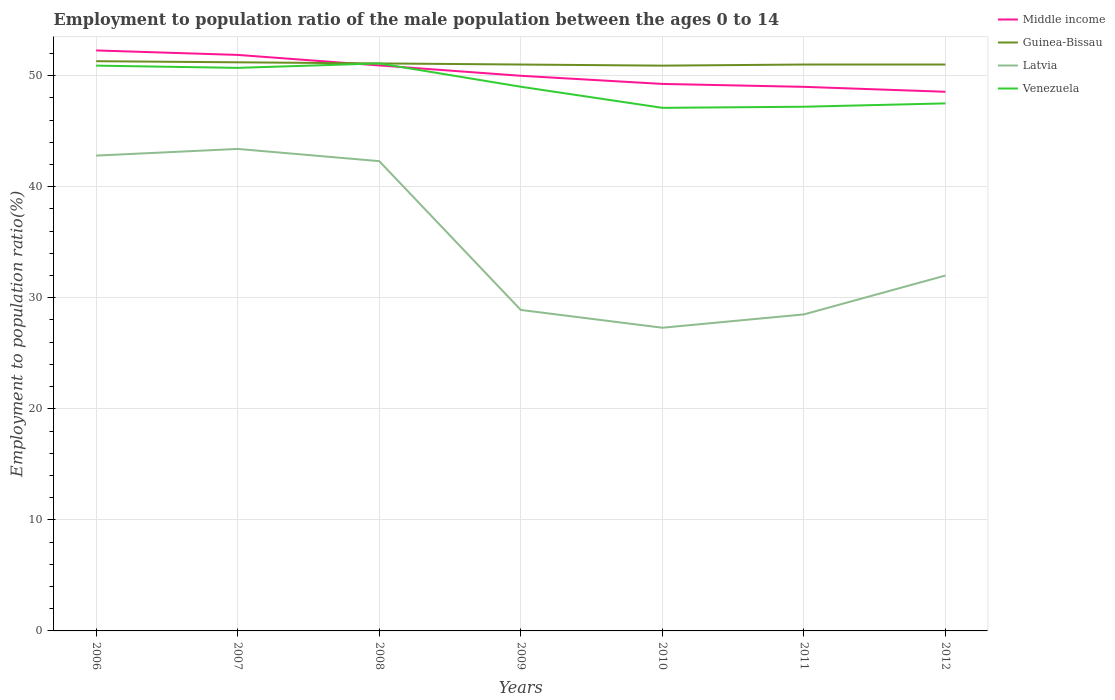How many different coloured lines are there?
Ensure brevity in your answer.  4. Does the line corresponding to Middle income intersect with the line corresponding to Venezuela?
Offer a very short reply. Yes. Is the number of lines equal to the number of legend labels?
Ensure brevity in your answer.  Yes. Across all years, what is the maximum employment to population ratio in Latvia?
Give a very brief answer. 27.3. What is the total employment to population ratio in Latvia in the graph?
Your answer should be very brief. 13.9. What is the difference between the highest and the second highest employment to population ratio in Latvia?
Your answer should be compact. 16.1. What is the difference between the highest and the lowest employment to population ratio in Middle income?
Keep it short and to the point. 3. Is the employment to population ratio in Venezuela strictly greater than the employment to population ratio in Latvia over the years?
Keep it short and to the point. No. How many lines are there?
Your response must be concise. 4. How many years are there in the graph?
Make the answer very short. 7. What is the difference between two consecutive major ticks on the Y-axis?
Offer a very short reply. 10. Does the graph contain grids?
Ensure brevity in your answer.  Yes. Where does the legend appear in the graph?
Your answer should be compact. Top right. How many legend labels are there?
Make the answer very short. 4. What is the title of the graph?
Make the answer very short. Employment to population ratio of the male population between the ages 0 to 14. What is the Employment to population ratio(%) in Middle income in 2006?
Your response must be concise. 52.27. What is the Employment to population ratio(%) of Guinea-Bissau in 2006?
Offer a very short reply. 51.3. What is the Employment to population ratio(%) in Latvia in 2006?
Ensure brevity in your answer.  42.8. What is the Employment to population ratio(%) of Venezuela in 2006?
Give a very brief answer. 50.9. What is the Employment to population ratio(%) of Middle income in 2007?
Your response must be concise. 51.87. What is the Employment to population ratio(%) in Guinea-Bissau in 2007?
Make the answer very short. 51.2. What is the Employment to population ratio(%) in Latvia in 2007?
Provide a short and direct response. 43.4. What is the Employment to population ratio(%) in Venezuela in 2007?
Your response must be concise. 50.7. What is the Employment to population ratio(%) in Middle income in 2008?
Give a very brief answer. 50.92. What is the Employment to population ratio(%) in Guinea-Bissau in 2008?
Give a very brief answer. 51.1. What is the Employment to population ratio(%) in Latvia in 2008?
Your response must be concise. 42.3. What is the Employment to population ratio(%) of Venezuela in 2008?
Your response must be concise. 51.1. What is the Employment to population ratio(%) of Middle income in 2009?
Keep it short and to the point. 49.99. What is the Employment to population ratio(%) in Latvia in 2009?
Keep it short and to the point. 28.9. What is the Employment to population ratio(%) in Venezuela in 2009?
Your answer should be very brief. 49. What is the Employment to population ratio(%) in Middle income in 2010?
Your answer should be very brief. 49.25. What is the Employment to population ratio(%) in Guinea-Bissau in 2010?
Offer a terse response. 50.9. What is the Employment to population ratio(%) in Latvia in 2010?
Offer a very short reply. 27.3. What is the Employment to population ratio(%) in Venezuela in 2010?
Give a very brief answer. 47.1. What is the Employment to population ratio(%) of Middle income in 2011?
Provide a short and direct response. 48.99. What is the Employment to population ratio(%) in Guinea-Bissau in 2011?
Provide a succinct answer. 51. What is the Employment to population ratio(%) of Venezuela in 2011?
Offer a very short reply. 47.2. What is the Employment to population ratio(%) of Middle income in 2012?
Your answer should be compact. 48.55. What is the Employment to population ratio(%) of Venezuela in 2012?
Your answer should be compact. 47.5. Across all years, what is the maximum Employment to population ratio(%) in Middle income?
Offer a very short reply. 52.27. Across all years, what is the maximum Employment to population ratio(%) of Guinea-Bissau?
Your answer should be compact. 51.3. Across all years, what is the maximum Employment to population ratio(%) in Latvia?
Provide a succinct answer. 43.4. Across all years, what is the maximum Employment to population ratio(%) in Venezuela?
Your response must be concise. 51.1. Across all years, what is the minimum Employment to population ratio(%) in Middle income?
Give a very brief answer. 48.55. Across all years, what is the minimum Employment to population ratio(%) in Guinea-Bissau?
Provide a succinct answer. 50.9. Across all years, what is the minimum Employment to population ratio(%) of Latvia?
Give a very brief answer. 27.3. Across all years, what is the minimum Employment to population ratio(%) in Venezuela?
Provide a succinct answer. 47.1. What is the total Employment to population ratio(%) in Middle income in the graph?
Provide a short and direct response. 351.83. What is the total Employment to population ratio(%) of Guinea-Bissau in the graph?
Your answer should be compact. 357.5. What is the total Employment to population ratio(%) in Latvia in the graph?
Ensure brevity in your answer.  245.2. What is the total Employment to population ratio(%) in Venezuela in the graph?
Give a very brief answer. 343.5. What is the difference between the Employment to population ratio(%) of Middle income in 2006 and that in 2007?
Ensure brevity in your answer.  0.4. What is the difference between the Employment to population ratio(%) of Latvia in 2006 and that in 2007?
Keep it short and to the point. -0.6. What is the difference between the Employment to population ratio(%) of Venezuela in 2006 and that in 2007?
Offer a terse response. 0.2. What is the difference between the Employment to population ratio(%) of Middle income in 2006 and that in 2008?
Keep it short and to the point. 1.35. What is the difference between the Employment to population ratio(%) in Venezuela in 2006 and that in 2008?
Make the answer very short. -0.2. What is the difference between the Employment to population ratio(%) of Middle income in 2006 and that in 2009?
Give a very brief answer. 2.28. What is the difference between the Employment to population ratio(%) in Guinea-Bissau in 2006 and that in 2009?
Provide a short and direct response. 0.3. What is the difference between the Employment to population ratio(%) of Latvia in 2006 and that in 2009?
Ensure brevity in your answer.  13.9. What is the difference between the Employment to population ratio(%) in Venezuela in 2006 and that in 2009?
Keep it short and to the point. 1.9. What is the difference between the Employment to population ratio(%) in Middle income in 2006 and that in 2010?
Offer a very short reply. 3.01. What is the difference between the Employment to population ratio(%) in Guinea-Bissau in 2006 and that in 2010?
Make the answer very short. 0.4. What is the difference between the Employment to population ratio(%) of Venezuela in 2006 and that in 2010?
Your response must be concise. 3.8. What is the difference between the Employment to population ratio(%) in Middle income in 2006 and that in 2011?
Offer a very short reply. 3.28. What is the difference between the Employment to population ratio(%) of Latvia in 2006 and that in 2011?
Your response must be concise. 14.3. What is the difference between the Employment to population ratio(%) in Venezuela in 2006 and that in 2011?
Offer a terse response. 3.7. What is the difference between the Employment to population ratio(%) of Middle income in 2006 and that in 2012?
Provide a succinct answer. 3.72. What is the difference between the Employment to population ratio(%) of Venezuela in 2006 and that in 2012?
Offer a terse response. 3.4. What is the difference between the Employment to population ratio(%) in Middle income in 2007 and that in 2008?
Keep it short and to the point. 0.95. What is the difference between the Employment to population ratio(%) in Guinea-Bissau in 2007 and that in 2008?
Provide a short and direct response. 0.1. What is the difference between the Employment to population ratio(%) of Latvia in 2007 and that in 2008?
Provide a short and direct response. 1.1. What is the difference between the Employment to population ratio(%) of Middle income in 2007 and that in 2009?
Your response must be concise. 1.88. What is the difference between the Employment to population ratio(%) of Guinea-Bissau in 2007 and that in 2009?
Make the answer very short. 0.2. What is the difference between the Employment to population ratio(%) of Latvia in 2007 and that in 2009?
Provide a succinct answer. 14.5. What is the difference between the Employment to population ratio(%) in Venezuela in 2007 and that in 2009?
Provide a succinct answer. 1.7. What is the difference between the Employment to population ratio(%) in Middle income in 2007 and that in 2010?
Ensure brevity in your answer.  2.61. What is the difference between the Employment to population ratio(%) in Venezuela in 2007 and that in 2010?
Provide a succinct answer. 3.6. What is the difference between the Employment to population ratio(%) of Middle income in 2007 and that in 2011?
Offer a very short reply. 2.88. What is the difference between the Employment to population ratio(%) in Guinea-Bissau in 2007 and that in 2011?
Make the answer very short. 0.2. What is the difference between the Employment to population ratio(%) in Latvia in 2007 and that in 2011?
Offer a terse response. 14.9. What is the difference between the Employment to population ratio(%) of Middle income in 2007 and that in 2012?
Offer a very short reply. 3.32. What is the difference between the Employment to population ratio(%) in Guinea-Bissau in 2007 and that in 2012?
Your answer should be compact. 0.2. What is the difference between the Employment to population ratio(%) in Latvia in 2007 and that in 2012?
Make the answer very short. 11.4. What is the difference between the Employment to population ratio(%) in Venezuela in 2007 and that in 2012?
Offer a terse response. 3.2. What is the difference between the Employment to population ratio(%) in Middle income in 2008 and that in 2009?
Provide a short and direct response. 0.93. What is the difference between the Employment to population ratio(%) of Latvia in 2008 and that in 2009?
Provide a succinct answer. 13.4. What is the difference between the Employment to population ratio(%) in Middle income in 2008 and that in 2010?
Offer a terse response. 1.66. What is the difference between the Employment to population ratio(%) in Venezuela in 2008 and that in 2010?
Make the answer very short. 4. What is the difference between the Employment to population ratio(%) of Middle income in 2008 and that in 2011?
Ensure brevity in your answer.  1.93. What is the difference between the Employment to population ratio(%) of Venezuela in 2008 and that in 2011?
Provide a succinct answer. 3.9. What is the difference between the Employment to population ratio(%) of Middle income in 2008 and that in 2012?
Give a very brief answer. 2.37. What is the difference between the Employment to population ratio(%) in Venezuela in 2008 and that in 2012?
Ensure brevity in your answer.  3.6. What is the difference between the Employment to population ratio(%) in Middle income in 2009 and that in 2010?
Ensure brevity in your answer.  0.73. What is the difference between the Employment to population ratio(%) of Latvia in 2009 and that in 2010?
Offer a very short reply. 1.6. What is the difference between the Employment to population ratio(%) of Venezuela in 2009 and that in 2010?
Your answer should be very brief. 1.9. What is the difference between the Employment to population ratio(%) of Middle income in 2009 and that in 2011?
Provide a short and direct response. 1. What is the difference between the Employment to population ratio(%) in Latvia in 2009 and that in 2011?
Ensure brevity in your answer.  0.4. What is the difference between the Employment to population ratio(%) in Venezuela in 2009 and that in 2011?
Provide a succinct answer. 1.8. What is the difference between the Employment to population ratio(%) of Middle income in 2009 and that in 2012?
Provide a short and direct response. 1.44. What is the difference between the Employment to population ratio(%) of Guinea-Bissau in 2009 and that in 2012?
Keep it short and to the point. 0. What is the difference between the Employment to population ratio(%) of Middle income in 2010 and that in 2011?
Give a very brief answer. 0.26. What is the difference between the Employment to population ratio(%) in Guinea-Bissau in 2010 and that in 2011?
Offer a very short reply. -0.1. What is the difference between the Employment to population ratio(%) of Middle income in 2010 and that in 2012?
Ensure brevity in your answer.  0.71. What is the difference between the Employment to population ratio(%) in Middle income in 2011 and that in 2012?
Offer a terse response. 0.44. What is the difference between the Employment to population ratio(%) of Guinea-Bissau in 2011 and that in 2012?
Your response must be concise. 0. What is the difference between the Employment to population ratio(%) of Latvia in 2011 and that in 2012?
Make the answer very short. -3.5. What is the difference between the Employment to population ratio(%) of Middle income in 2006 and the Employment to population ratio(%) of Guinea-Bissau in 2007?
Your answer should be compact. 1.07. What is the difference between the Employment to population ratio(%) in Middle income in 2006 and the Employment to population ratio(%) in Latvia in 2007?
Make the answer very short. 8.87. What is the difference between the Employment to population ratio(%) in Middle income in 2006 and the Employment to population ratio(%) in Venezuela in 2007?
Offer a terse response. 1.57. What is the difference between the Employment to population ratio(%) of Guinea-Bissau in 2006 and the Employment to population ratio(%) of Latvia in 2007?
Provide a succinct answer. 7.9. What is the difference between the Employment to population ratio(%) in Middle income in 2006 and the Employment to population ratio(%) in Guinea-Bissau in 2008?
Provide a short and direct response. 1.17. What is the difference between the Employment to population ratio(%) of Middle income in 2006 and the Employment to population ratio(%) of Latvia in 2008?
Your answer should be very brief. 9.97. What is the difference between the Employment to population ratio(%) of Middle income in 2006 and the Employment to population ratio(%) of Venezuela in 2008?
Offer a very short reply. 1.17. What is the difference between the Employment to population ratio(%) of Guinea-Bissau in 2006 and the Employment to population ratio(%) of Latvia in 2008?
Provide a short and direct response. 9. What is the difference between the Employment to population ratio(%) in Guinea-Bissau in 2006 and the Employment to population ratio(%) in Venezuela in 2008?
Keep it short and to the point. 0.2. What is the difference between the Employment to population ratio(%) of Latvia in 2006 and the Employment to population ratio(%) of Venezuela in 2008?
Keep it short and to the point. -8.3. What is the difference between the Employment to population ratio(%) in Middle income in 2006 and the Employment to population ratio(%) in Guinea-Bissau in 2009?
Offer a terse response. 1.27. What is the difference between the Employment to population ratio(%) of Middle income in 2006 and the Employment to population ratio(%) of Latvia in 2009?
Offer a terse response. 23.37. What is the difference between the Employment to population ratio(%) of Middle income in 2006 and the Employment to population ratio(%) of Venezuela in 2009?
Your answer should be very brief. 3.27. What is the difference between the Employment to population ratio(%) of Guinea-Bissau in 2006 and the Employment to population ratio(%) of Latvia in 2009?
Your answer should be compact. 22.4. What is the difference between the Employment to population ratio(%) in Guinea-Bissau in 2006 and the Employment to population ratio(%) in Venezuela in 2009?
Ensure brevity in your answer.  2.3. What is the difference between the Employment to population ratio(%) of Middle income in 2006 and the Employment to population ratio(%) of Guinea-Bissau in 2010?
Your answer should be very brief. 1.37. What is the difference between the Employment to population ratio(%) in Middle income in 2006 and the Employment to population ratio(%) in Latvia in 2010?
Keep it short and to the point. 24.97. What is the difference between the Employment to population ratio(%) in Middle income in 2006 and the Employment to population ratio(%) in Venezuela in 2010?
Keep it short and to the point. 5.17. What is the difference between the Employment to population ratio(%) in Middle income in 2006 and the Employment to population ratio(%) in Guinea-Bissau in 2011?
Your answer should be compact. 1.27. What is the difference between the Employment to population ratio(%) of Middle income in 2006 and the Employment to population ratio(%) of Latvia in 2011?
Keep it short and to the point. 23.77. What is the difference between the Employment to population ratio(%) in Middle income in 2006 and the Employment to population ratio(%) in Venezuela in 2011?
Ensure brevity in your answer.  5.07. What is the difference between the Employment to population ratio(%) of Guinea-Bissau in 2006 and the Employment to population ratio(%) of Latvia in 2011?
Offer a very short reply. 22.8. What is the difference between the Employment to population ratio(%) in Guinea-Bissau in 2006 and the Employment to population ratio(%) in Venezuela in 2011?
Your response must be concise. 4.1. What is the difference between the Employment to population ratio(%) of Latvia in 2006 and the Employment to population ratio(%) of Venezuela in 2011?
Your answer should be compact. -4.4. What is the difference between the Employment to population ratio(%) in Middle income in 2006 and the Employment to population ratio(%) in Guinea-Bissau in 2012?
Provide a short and direct response. 1.27. What is the difference between the Employment to population ratio(%) in Middle income in 2006 and the Employment to population ratio(%) in Latvia in 2012?
Offer a terse response. 20.27. What is the difference between the Employment to population ratio(%) of Middle income in 2006 and the Employment to population ratio(%) of Venezuela in 2012?
Your answer should be compact. 4.77. What is the difference between the Employment to population ratio(%) of Guinea-Bissau in 2006 and the Employment to population ratio(%) of Latvia in 2012?
Provide a short and direct response. 19.3. What is the difference between the Employment to population ratio(%) of Guinea-Bissau in 2006 and the Employment to population ratio(%) of Venezuela in 2012?
Keep it short and to the point. 3.8. What is the difference between the Employment to population ratio(%) in Middle income in 2007 and the Employment to population ratio(%) in Guinea-Bissau in 2008?
Provide a succinct answer. 0.77. What is the difference between the Employment to population ratio(%) in Middle income in 2007 and the Employment to population ratio(%) in Latvia in 2008?
Offer a terse response. 9.57. What is the difference between the Employment to population ratio(%) of Middle income in 2007 and the Employment to population ratio(%) of Venezuela in 2008?
Provide a short and direct response. 0.77. What is the difference between the Employment to population ratio(%) of Middle income in 2007 and the Employment to population ratio(%) of Guinea-Bissau in 2009?
Provide a succinct answer. 0.87. What is the difference between the Employment to population ratio(%) of Middle income in 2007 and the Employment to population ratio(%) of Latvia in 2009?
Keep it short and to the point. 22.97. What is the difference between the Employment to population ratio(%) of Middle income in 2007 and the Employment to population ratio(%) of Venezuela in 2009?
Your answer should be very brief. 2.87. What is the difference between the Employment to population ratio(%) of Guinea-Bissau in 2007 and the Employment to population ratio(%) of Latvia in 2009?
Give a very brief answer. 22.3. What is the difference between the Employment to population ratio(%) in Guinea-Bissau in 2007 and the Employment to population ratio(%) in Venezuela in 2009?
Your answer should be very brief. 2.2. What is the difference between the Employment to population ratio(%) of Middle income in 2007 and the Employment to population ratio(%) of Guinea-Bissau in 2010?
Keep it short and to the point. 0.97. What is the difference between the Employment to population ratio(%) in Middle income in 2007 and the Employment to population ratio(%) in Latvia in 2010?
Provide a succinct answer. 24.57. What is the difference between the Employment to population ratio(%) in Middle income in 2007 and the Employment to population ratio(%) in Venezuela in 2010?
Your response must be concise. 4.77. What is the difference between the Employment to population ratio(%) of Guinea-Bissau in 2007 and the Employment to population ratio(%) of Latvia in 2010?
Your answer should be very brief. 23.9. What is the difference between the Employment to population ratio(%) of Latvia in 2007 and the Employment to population ratio(%) of Venezuela in 2010?
Make the answer very short. -3.7. What is the difference between the Employment to population ratio(%) in Middle income in 2007 and the Employment to population ratio(%) in Guinea-Bissau in 2011?
Provide a succinct answer. 0.87. What is the difference between the Employment to population ratio(%) in Middle income in 2007 and the Employment to population ratio(%) in Latvia in 2011?
Ensure brevity in your answer.  23.37. What is the difference between the Employment to population ratio(%) in Middle income in 2007 and the Employment to population ratio(%) in Venezuela in 2011?
Your answer should be compact. 4.67. What is the difference between the Employment to population ratio(%) in Guinea-Bissau in 2007 and the Employment to population ratio(%) in Latvia in 2011?
Keep it short and to the point. 22.7. What is the difference between the Employment to population ratio(%) in Middle income in 2007 and the Employment to population ratio(%) in Guinea-Bissau in 2012?
Keep it short and to the point. 0.87. What is the difference between the Employment to population ratio(%) in Middle income in 2007 and the Employment to population ratio(%) in Latvia in 2012?
Offer a terse response. 19.87. What is the difference between the Employment to population ratio(%) of Middle income in 2007 and the Employment to population ratio(%) of Venezuela in 2012?
Make the answer very short. 4.37. What is the difference between the Employment to population ratio(%) in Latvia in 2007 and the Employment to population ratio(%) in Venezuela in 2012?
Offer a terse response. -4.1. What is the difference between the Employment to population ratio(%) in Middle income in 2008 and the Employment to population ratio(%) in Guinea-Bissau in 2009?
Your response must be concise. -0.08. What is the difference between the Employment to population ratio(%) in Middle income in 2008 and the Employment to population ratio(%) in Latvia in 2009?
Provide a succinct answer. 22.02. What is the difference between the Employment to population ratio(%) in Middle income in 2008 and the Employment to population ratio(%) in Venezuela in 2009?
Offer a very short reply. 1.92. What is the difference between the Employment to population ratio(%) in Guinea-Bissau in 2008 and the Employment to population ratio(%) in Latvia in 2009?
Your response must be concise. 22.2. What is the difference between the Employment to population ratio(%) in Guinea-Bissau in 2008 and the Employment to population ratio(%) in Venezuela in 2009?
Ensure brevity in your answer.  2.1. What is the difference between the Employment to population ratio(%) of Latvia in 2008 and the Employment to population ratio(%) of Venezuela in 2009?
Give a very brief answer. -6.7. What is the difference between the Employment to population ratio(%) of Middle income in 2008 and the Employment to population ratio(%) of Guinea-Bissau in 2010?
Your response must be concise. 0.02. What is the difference between the Employment to population ratio(%) of Middle income in 2008 and the Employment to population ratio(%) of Latvia in 2010?
Your answer should be compact. 23.62. What is the difference between the Employment to population ratio(%) in Middle income in 2008 and the Employment to population ratio(%) in Venezuela in 2010?
Give a very brief answer. 3.82. What is the difference between the Employment to population ratio(%) in Guinea-Bissau in 2008 and the Employment to population ratio(%) in Latvia in 2010?
Ensure brevity in your answer.  23.8. What is the difference between the Employment to population ratio(%) in Middle income in 2008 and the Employment to population ratio(%) in Guinea-Bissau in 2011?
Ensure brevity in your answer.  -0.08. What is the difference between the Employment to population ratio(%) of Middle income in 2008 and the Employment to population ratio(%) of Latvia in 2011?
Your answer should be compact. 22.42. What is the difference between the Employment to population ratio(%) of Middle income in 2008 and the Employment to population ratio(%) of Venezuela in 2011?
Your answer should be very brief. 3.72. What is the difference between the Employment to population ratio(%) of Guinea-Bissau in 2008 and the Employment to population ratio(%) of Latvia in 2011?
Give a very brief answer. 22.6. What is the difference between the Employment to population ratio(%) in Middle income in 2008 and the Employment to population ratio(%) in Guinea-Bissau in 2012?
Offer a terse response. -0.08. What is the difference between the Employment to population ratio(%) in Middle income in 2008 and the Employment to population ratio(%) in Latvia in 2012?
Your answer should be compact. 18.92. What is the difference between the Employment to population ratio(%) in Middle income in 2008 and the Employment to population ratio(%) in Venezuela in 2012?
Offer a terse response. 3.42. What is the difference between the Employment to population ratio(%) in Guinea-Bissau in 2008 and the Employment to population ratio(%) in Venezuela in 2012?
Provide a short and direct response. 3.6. What is the difference between the Employment to population ratio(%) in Latvia in 2008 and the Employment to population ratio(%) in Venezuela in 2012?
Offer a terse response. -5.2. What is the difference between the Employment to population ratio(%) in Middle income in 2009 and the Employment to population ratio(%) in Guinea-Bissau in 2010?
Make the answer very short. -0.91. What is the difference between the Employment to population ratio(%) of Middle income in 2009 and the Employment to population ratio(%) of Latvia in 2010?
Offer a terse response. 22.69. What is the difference between the Employment to population ratio(%) in Middle income in 2009 and the Employment to population ratio(%) in Venezuela in 2010?
Your answer should be very brief. 2.89. What is the difference between the Employment to population ratio(%) in Guinea-Bissau in 2009 and the Employment to population ratio(%) in Latvia in 2010?
Ensure brevity in your answer.  23.7. What is the difference between the Employment to population ratio(%) of Guinea-Bissau in 2009 and the Employment to population ratio(%) of Venezuela in 2010?
Your answer should be very brief. 3.9. What is the difference between the Employment to population ratio(%) in Latvia in 2009 and the Employment to population ratio(%) in Venezuela in 2010?
Make the answer very short. -18.2. What is the difference between the Employment to population ratio(%) in Middle income in 2009 and the Employment to population ratio(%) in Guinea-Bissau in 2011?
Make the answer very short. -1.01. What is the difference between the Employment to population ratio(%) in Middle income in 2009 and the Employment to population ratio(%) in Latvia in 2011?
Provide a short and direct response. 21.49. What is the difference between the Employment to population ratio(%) of Middle income in 2009 and the Employment to population ratio(%) of Venezuela in 2011?
Provide a short and direct response. 2.79. What is the difference between the Employment to population ratio(%) of Guinea-Bissau in 2009 and the Employment to population ratio(%) of Venezuela in 2011?
Make the answer very short. 3.8. What is the difference between the Employment to population ratio(%) of Latvia in 2009 and the Employment to population ratio(%) of Venezuela in 2011?
Offer a very short reply. -18.3. What is the difference between the Employment to population ratio(%) of Middle income in 2009 and the Employment to population ratio(%) of Guinea-Bissau in 2012?
Ensure brevity in your answer.  -1.01. What is the difference between the Employment to population ratio(%) of Middle income in 2009 and the Employment to population ratio(%) of Latvia in 2012?
Provide a short and direct response. 17.99. What is the difference between the Employment to population ratio(%) in Middle income in 2009 and the Employment to population ratio(%) in Venezuela in 2012?
Keep it short and to the point. 2.49. What is the difference between the Employment to population ratio(%) in Guinea-Bissau in 2009 and the Employment to population ratio(%) in Latvia in 2012?
Provide a succinct answer. 19. What is the difference between the Employment to population ratio(%) of Latvia in 2009 and the Employment to population ratio(%) of Venezuela in 2012?
Provide a succinct answer. -18.6. What is the difference between the Employment to population ratio(%) of Middle income in 2010 and the Employment to population ratio(%) of Guinea-Bissau in 2011?
Keep it short and to the point. -1.75. What is the difference between the Employment to population ratio(%) of Middle income in 2010 and the Employment to population ratio(%) of Latvia in 2011?
Offer a terse response. 20.75. What is the difference between the Employment to population ratio(%) in Middle income in 2010 and the Employment to population ratio(%) in Venezuela in 2011?
Keep it short and to the point. 2.05. What is the difference between the Employment to population ratio(%) in Guinea-Bissau in 2010 and the Employment to population ratio(%) in Latvia in 2011?
Ensure brevity in your answer.  22.4. What is the difference between the Employment to population ratio(%) of Latvia in 2010 and the Employment to population ratio(%) of Venezuela in 2011?
Give a very brief answer. -19.9. What is the difference between the Employment to population ratio(%) of Middle income in 2010 and the Employment to population ratio(%) of Guinea-Bissau in 2012?
Offer a very short reply. -1.75. What is the difference between the Employment to population ratio(%) in Middle income in 2010 and the Employment to population ratio(%) in Latvia in 2012?
Offer a terse response. 17.25. What is the difference between the Employment to population ratio(%) in Middle income in 2010 and the Employment to population ratio(%) in Venezuela in 2012?
Ensure brevity in your answer.  1.75. What is the difference between the Employment to population ratio(%) of Latvia in 2010 and the Employment to population ratio(%) of Venezuela in 2012?
Ensure brevity in your answer.  -20.2. What is the difference between the Employment to population ratio(%) in Middle income in 2011 and the Employment to population ratio(%) in Guinea-Bissau in 2012?
Your response must be concise. -2.01. What is the difference between the Employment to population ratio(%) in Middle income in 2011 and the Employment to population ratio(%) in Latvia in 2012?
Offer a terse response. 16.99. What is the difference between the Employment to population ratio(%) in Middle income in 2011 and the Employment to population ratio(%) in Venezuela in 2012?
Your answer should be compact. 1.49. What is the difference between the Employment to population ratio(%) in Guinea-Bissau in 2011 and the Employment to population ratio(%) in Latvia in 2012?
Provide a short and direct response. 19. What is the difference between the Employment to population ratio(%) of Guinea-Bissau in 2011 and the Employment to population ratio(%) of Venezuela in 2012?
Provide a succinct answer. 3.5. What is the average Employment to population ratio(%) in Middle income per year?
Make the answer very short. 50.26. What is the average Employment to population ratio(%) of Guinea-Bissau per year?
Your answer should be very brief. 51.07. What is the average Employment to population ratio(%) of Latvia per year?
Your answer should be very brief. 35.03. What is the average Employment to population ratio(%) of Venezuela per year?
Make the answer very short. 49.07. In the year 2006, what is the difference between the Employment to population ratio(%) in Middle income and Employment to population ratio(%) in Guinea-Bissau?
Keep it short and to the point. 0.97. In the year 2006, what is the difference between the Employment to population ratio(%) in Middle income and Employment to population ratio(%) in Latvia?
Provide a succinct answer. 9.47. In the year 2006, what is the difference between the Employment to population ratio(%) in Middle income and Employment to population ratio(%) in Venezuela?
Your answer should be very brief. 1.37. In the year 2006, what is the difference between the Employment to population ratio(%) of Guinea-Bissau and Employment to population ratio(%) of Venezuela?
Keep it short and to the point. 0.4. In the year 2007, what is the difference between the Employment to population ratio(%) of Middle income and Employment to population ratio(%) of Guinea-Bissau?
Your answer should be compact. 0.67. In the year 2007, what is the difference between the Employment to population ratio(%) in Middle income and Employment to population ratio(%) in Latvia?
Give a very brief answer. 8.47. In the year 2007, what is the difference between the Employment to population ratio(%) of Middle income and Employment to population ratio(%) of Venezuela?
Provide a short and direct response. 1.17. In the year 2007, what is the difference between the Employment to population ratio(%) in Guinea-Bissau and Employment to population ratio(%) in Latvia?
Provide a succinct answer. 7.8. In the year 2007, what is the difference between the Employment to population ratio(%) in Guinea-Bissau and Employment to population ratio(%) in Venezuela?
Make the answer very short. 0.5. In the year 2007, what is the difference between the Employment to population ratio(%) in Latvia and Employment to population ratio(%) in Venezuela?
Your answer should be very brief. -7.3. In the year 2008, what is the difference between the Employment to population ratio(%) of Middle income and Employment to population ratio(%) of Guinea-Bissau?
Provide a succinct answer. -0.18. In the year 2008, what is the difference between the Employment to population ratio(%) in Middle income and Employment to population ratio(%) in Latvia?
Make the answer very short. 8.62. In the year 2008, what is the difference between the Employment to population ratio(%) in Middle income and Employment to population ratio(%) in Venezuela?
Provide a short and direct response. -0.18. In the year 2008, what is the difference between the Employment to population ratio(%) of Guinea-Bissau and Employment to population ratio(%) of Venezuela?
Make the answer very short. 0. In the year 2009, what is the difference between the Employment to population ratio(%) in Middle income and Employment to population ratio(%) in Guinea-Bissau?
Your answer should be very brief. -1.01. In the year 2009, what is the difference between the Employment to population ratio(%) in Middle income and Employment to population ratio(%) in Latvia?
Ensure brevity in your answer.  21.09. In the year 2009, what is the difference between the Employment to population ratio(%) in Middle income and Employment to population ratio(%) in Venezuela?
Make the answer very short. 0.99. In the year 2009, what is the difference between the Employment to population ratio(%) of Guinea-Bissau and Employment to population ratio(%) of Latvia?
Ensure brevity in your answer.  22.1. In the year 2009, what is the difference between the Employment to population ratio(%) of Latvia and Employment to population ratio(%) of Venezuela?
Offer a terse response. -20.1. In the year 2010, what is the difference between the Employment to population ratio(%) of Middle income and Employment to population ratio(%) of Guinea-Bissau?
Offer a terse response. -1.65. In the year 2010, what is the difference between the Employment to population ratio(%) of Middle income and Employment to population ratio(%) of Latvia?
Make the answer very short. 21.95. In the year 2010, what is the difference between the Employment to population ratio(%) of Middle income and Employment to population ratio(%) of Venezuela?
Offer a terse response. 2.15. In the year 2010, what is the difference between the Employment to population ratio(%) in Guinea-Bissau and Employment to population ratio(%) in Latvia?
Offer a very short reply. 23.6. In the year 2010, what is the difference between the Employment to population ratio(%) of Latvia and Employment to population ratio(%) of Venezuela?
Your answer should be compact. -19.8. In the year 2011, what is the difference between the Employment to population ratio(%) of Middle income and Employment to population ratio(%) of Guinea-Bissau?
Offer a terse response. -2.01. In the year 2011, what is the difference between the Employment to population ratio(%) of Middle income and Employment to population ratio(%) of Latvia?
Offer a very short reply. 20.49. In the year 2011, what is the difference between the Employment to population ratio(%) of Middle income and Employment to population ratio(%) of Venezuela?
Your answer should be very brief. 1.79. In the year 2011, what is the difference between the Employment to population ratio(%) of Guinea-Bissau and Employment to population ratio(%) of Venezuela?
Give a very brief answer. 3.8. In the year 2011, what is the difference between the Employment to population ratio(%) in Latvia and Employment to population ratio(%) in Venezuela?
Keep it short and to the point. -18.7. In the year 2012, what is the difference between the Employment to population ratio(%) of Middle income and Employment to population ratio(%) of Guinea-Bissau?
Your response must be concise. -2.45. In the year 2012, what is the difference between the Employment to population ratio(%) in Middle income and Employment to population ratio(%) in Latvia?
Your response must be concise. 16.55. In the year 2012, what is the difference between the Employment to population ratio(%) of Middle income and Employment to population ratio(%) of Venezuela?
Offer a terse response. 1.05. In the year 2012, what is the difference between the Employment to population ratio(%) in Latvia and Employment to population ratio(%) in Venezuela?
Offer a terse response. -15.5. What is the ratio of the Employment to population ratio(%) in Guinea-Bissau in 2006 to that in 2007?
Give a very brief answer. 1. What is the ratio of the Employment to population ratio(%) in Latvia in 2006 to that in 2007?
Your answer should be very brief. 0.99. What is the ratio of the Employment to population ratio(%) in Venezuela in 2006 to that in 2007?
Your answer should be very brief. 1. What is the ratio of the Employment to population ratio(%) of Middle income in 2006 to that in 2008?
Provide a succinct answer. 1.03. What is the ratio of the Employment to population ratio(%) of Latvia in 2006 to that in 2008?
Make the answer very short. 1.01. What is the ratio of the Employment to population ratio(%) in Middle income in 2006 to that in 2009?
Keep it short and to the point. 1.05. What is the ratio of the Employment to population ratio(%) of Guinea-Bissau in 2006 to that in 2009?
Offer a terse response. 1.01. What is the ratio of the Employment to population ratio(%) in Latvia in 2006 to that in 2009?
Offer a very short reply. 1.48. What is the ratio of the Employment to population ratio(%) of Venezuela in 2006 to that in 2009?
Your response must be concise. 1.04. What is the ratio of the Employment to population ratio(%) of Middle income in 2006 to that in 2010?
Make the answer very short. 1.06. What is the ratio of the Employment to population ratio(%) of Guinea-Bissau in 2006 to that in 2010?
Offer a very short reply. 1.01. What is the ratio of the Employment to population ratio(%) of Latvia in 2006 to that in 2010?
Keep it short and to the point. 1.57. What is the ratio of the Employment to population ratio(%) of Venezuela in 2006 to that in 2010?
Your answer should be compact. 1.08. What is the ratio of the Employment to population ratio(%) in Middle income in 2006 to that in 2011?
Give a very brief answer. 1.07. What is the ratio of the Employment to population ratio(%) in Guinea-Bissau in 2006 to that in 2011?
Your response must be concise. 1.01. What is the ratio of the Employment to population ratio(%) in Latvia in 2006 to that in 2011?
Provide a short and direct response. 1.5. What is the ratio of the Employment to population ratio(%) in Venezuela in 2006 to that in 2011?
Your response must be concise. 1.08. What is the ratio of the Employment to population ratio(%) of Middle income in 2006 to that in 2012?
Provide a short and direct response. 1.08. What is the ratio of the Employment to population ratio(%) of Guinea-Bissau in 2006 to that in 2012?
Provide a succinct answer. 1.01. What is the ratio of the Employment to population ratio(%) in Latvia in 2006 to that in 2012?
Provide a short and direct response. 1.34. What is the ratio of the Employment to population ratio(%) in Venezuela in 2006 to that in 2012?
Give a very brief answer. 1.07. What is the ratio of the Employment to population ratio(%) of Middle income in 2007 to that in 2008?
Give a very brief answer. 1.02. What is the ratio of the Employment to population ratio(%) of Guinea-Bissau in 2007 to that in 2008?
Your answer should be very brief. 1. What is the ratio of the Employment to population ratio(%) of Middle income in 2007 to that in 2009?
Offer a very short reply. 1.04. What is the ratio of the Employment to population ratio(%) of Guinea-Bissau in 2007 to that in 2009?
Offer a terse response. 1. What is the ratio of the Employment to population ratio(%) in Latvia in 2007 to that in 2009?
Make the answer very short. 1.5. What is the ratio of the Employment to population ratio(%) of Venezuela in 2007 to that in 2009?
Offer a very short reply. 1.03. What is the ratio of the Employment to population ratio(%) in Middle income in 2007 to that in 2010?
Your response must be concise. 1.05. What is the ratio of the Employment to population ratio(%) of Guinea-Bissau in 2007 to that in 2010?
Your answer should be very brief. 1.01. What is the ratio of the Employment to population ratio(%) of Latvia in 2007 to that in 2010?
Keep it short and to the point. 1.59. What is the ratio of the Employment to population ratio(%) in Venezuela in 2007 to that in 2010?
Keep it short and to the point. 1.08. What is the ratio of the Employment to population ratio(%) of Middle income in 2007 to that in 2011?
Give a very brief answer. 1.06. What is the ratio of the Employment to population ratio(%) in Guinea-Bissau in 2007 to that in 2011?
Your response must be concise. 1. What is the ratio of the Employment to population ratio(%) in Latvia in 2007 to that in 2011?
Make the answer very short. 1.52. What is the ratio of the Employment to population ratio(%) in Venezuela in 2007 to that in 2011?
Offer a terse response. 1.07. What is the ratio of the Employment to population ratio(%) of Middle income in 2007 to that in 2012?
Provide a succinct answer. 1.07. What is the ratio of the Employment to population ratio(%) in Guinea-Bissau in 2007 to that in 2012?
Make the answer very short. 1. What is the ratio of the Employment to population ratio(%) of Latvia in 2007 to that in 2012?
Give a very brief answer. 1.36. What is the ratio of the Employment to population ratio(%) of Venezuela in 2007 to that in 2012?
Your answer should be compact. 1.07. What is the ratio of the Employment to population ratio(%) in Middle income in 2008 to that in 2009?
Your answer should be compact. 1.02. What is the ratio of the Employment to population ratio(%) of Guinea-Bissau in 2008 to that in 2009?
Give a very brief answer. 1. What is the ratio of the Employment to population ratio(%) of Latvia in 2008 to that in 2009?
Give a very brief answer. 1.46. What is the ratio of the Employment to population ratio(%) of Venezuela in 2008 to that in 2009?
Offer a very short reply. 1.04. What is the ratio of the Employment to population ratio(%) of Middle income in 2008 to that in 2010?
Offer a very short reply. 1.03. What is the ratio of the Employment to population ratio(%) of Guinea-Bissau in 2008 to that in 2010?
Provide a succinct answer. 1. What is the ratio of the Employment to population ratio(%) in Latvia in 2008 to that in 2010?
Give a very brief answer. 1.55. What is the ratio of the Employment to population ratio(%) of Venezuela in 2008 to that in 2010?
Offer a very short reply. 1.08. What is the ratio of the Employment to population ratio(%) in Middle income in 2008 to that in 2011?
Your response must be concise. 1.04. What is the ratio of the Employment to population ratio(%) of Latvia in 2008 to that in 2011?
Ensure brevity in your answer.  1.48. What is the ratio of the Employment to population ratio(%) of Venezuela in 2008 to that in 2011?
Your response must be concise. 1.08. What is the ratio of the Employment to population ratio(%) of Middle income in 2008 to that in 2012?
Make the answer very short. 1.05. What is the ratio of the Employment to population ratio(%) in Latvia in 2008 to that in 2012?
Make the answer very short. 1.32. What is the ratio of the Employment to population ratio(%) of Venezuela in 2008 to that in 2012?
Your answer should be very brief. 1.08. What is the ratio of the Employment to population ratio(%) in Middle income in 2009 to that in 2010?
Keep it short and to the point. 1.01. What is the ratio of the Employment to population ratio(%) of Guinea-Bissau in 2009 to that in 2010?
Provide a succinct answer. 1. What is the ratio of the Employment to population ratio(%) of Latvia in 2009 to that in 2010?
Give a very brief answer. 1.06. What is the ratio of the Employment to population ratio(%) of Venezuela in 2009 to that in 2010?
Ensure brevity in your answer.  1.04. What is the ratio of the Employment to population ratio(%) in Middle income in 2009 to that in 2011?
Make the answer very short. 1.02. What is the ratio of the Employment to population ratio(%) of Guinea-Bissau in 2009 to that in 2011?
Keep it short and to the point. 1. What is the ratio of the Employment to population ratio(%) in Latvia in 2009 to that in 2011?
Offer a terse response. 1.01. What is the ratio of the Employment to population ratio(%) of Venezuela in 2009 to that in 2011?
Keep it short and to the point. 1.04. What is the ratio of the Employment to population ratio(%) of Middle income in 2009 to that in 2012?
Ensure brevity in your answer.  1.03. What is the ratio of the Employment to population ratio(%) of Guinea-Bissau in 2009 to that in 2012?
Give a very brief answer. 1. What is the ratio of the Employment to population ratio(%) of Latvia in 2009 to that in 2012?
Your response must be concise. 0.9. What is the ratio of the Employment to population ratio(%) of Venezuela in 2009 to that in 2012?
Offer a very short reply. 1.03. What is the ratio of the Employment to population ratio(%) in Middle income in 2010 to that in 2011?
Ensure brevity in your answer.  1.01. What is the ratio of the Employment to population ratio(%) of Guinea-Bissau in 2010 to that in 2011?
Keep it short and to the point. 1. What is the ratio of the Employment to population ratio(%) of Latvia in 2010 to that in 2011?
Your response must be concise. 0.96. What is the ratio of the Employment to population ratio(%) in Middle income in 2010 to that in 2012?
Your answer should be compact. 1.01. What is the ratio of the Employment to population ratio(%) of Latvia in 2010 to that in 2012?
Keep it short and to the point. 0.85. What is the ratio of the Employment to population ratio(%) of Venezuela in 2010 to that in 2012?
Your answer should be compact. 0.99. What is the ratio of the Employment to population ratio(%) of Middle income in 2011 to that in 2012?
Make the answer very short. 1.01. What is the ratio of the Employment to population ratio(%) in Latvia in 2011 to that in 2012?
Make the answer very short. 0.89. What is the ratio of the Employment to population ratio(%) in Venezuela in 2011 to that in 2012?
Ensure brevity in your answer.  0.99. What is the difference between the highest and the second highest Employment to population ratio(%) in Middle income?
Keep it short and to the point. 0.4. What is the difference between the highest and the second highest Employment to population ratio(%) of Venezuela?
Keep it short and to the point. 0.2. What is the difference between the highest and the lowest Employment to population ratio(%) in Middle income?
Offer a terse response. 3.72. What is the difference between the highest and the lowest Employment to population ratio(%) in Guinea-Bissau?
Your answer should be very brief. 0.4. What is the difference between the highest and the lowest Employment to population ratio(%) in Venezuela?
Give a very brief answer. 4. 